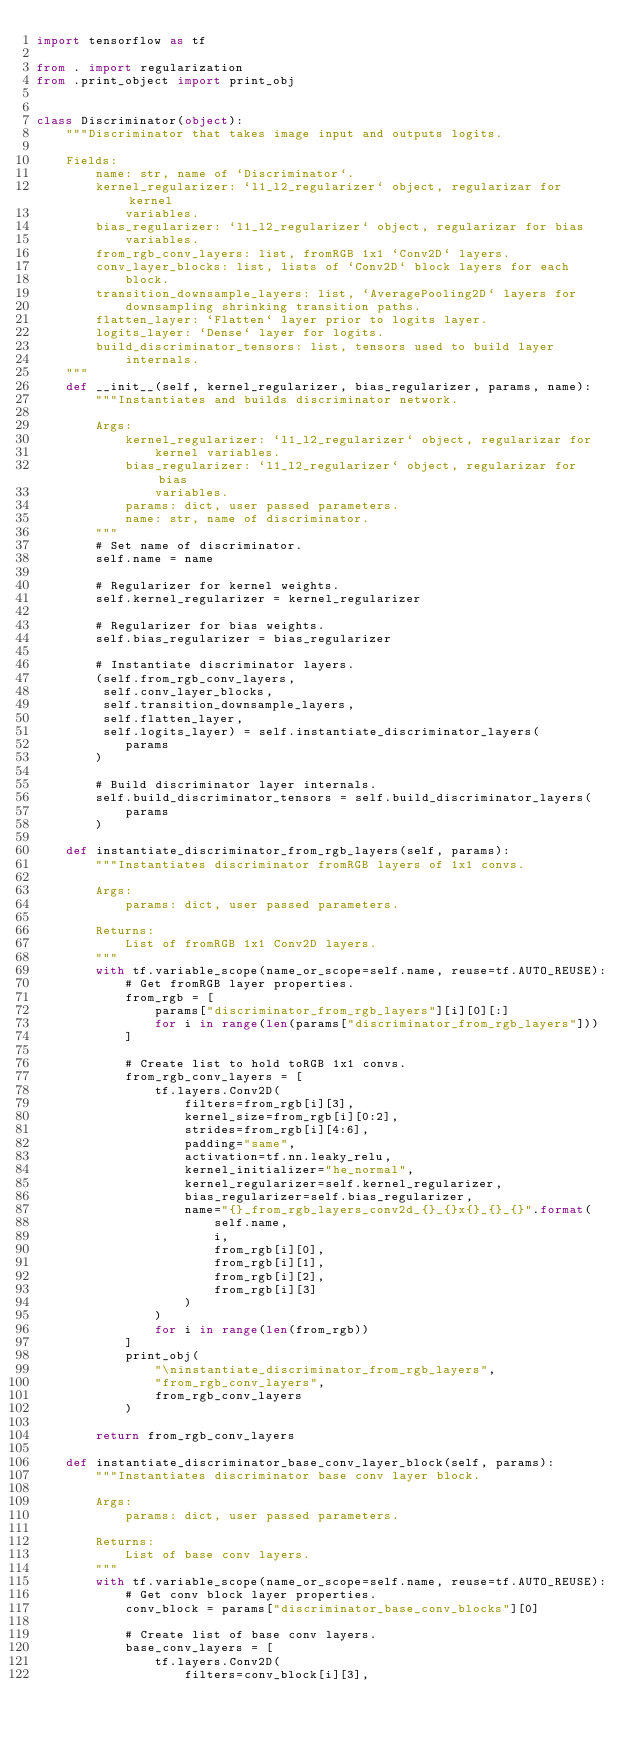<code> <loc_0><loc_0><loc_500><loc_500><_Python_>import tensorflow as tf

from . import regularization
from .print_object import print_obj


class Discriminator(object):
    """Discriminator that takes image input and outputs logits.

    Fields:
        name: str, name of `Discriminator`.
        kernel_regularizer: `l1_l2_regularizer` object, regularizar for kernel
            variables.
        bias_regularizer: `l1_l2_regularizer` object, regularizar for bias
            variables.
        from_rgb_conv_layers: list, fromRGB 1x1 `Conv2D` layers.
        conv_layer_blocks: list, lists of `Conv2D` block layers for each
            block.
        transition_downsample_layers: list, `AveragePooling2D` layers for
            downsampling shrinking transition paths.
        flatten_layer: `Flatten` layer prior to logits layer.
        logits_layer: `Dense` layer for logits.
        build_discriminator_tensors: list, tensors used to build layer
            internals.
    """
    def __init__(self, kernel_regularizer, bias_regularizer, params, name):
        """Instantiates and builds discriminator network.

        Args:
            kernel_regularizer: `l1_l2_regularizer` object, regularizar for
                kernel variables.
            bias_regularizer: `l1_l2_regularizer` object, regularizar for bias
                variables.
            params: dict, user passed parameters.
            name: str, name of discriminator.
        """
        # Set name of discriminator.
        self.name = name

        # Regularizer for kernel weights.
        self.kernel_regularizer = kernel_regularizer

        # Regularizer for bias weights.
        self.bias_regularizer = bias_regularizer

        # Instantiate discriminator layers.
        (self.from_rgb_conv_layers,
         self.conv_layer_blocks,
         self.transition_downsample_layers,
         self.flatten_layer,
         self.logits_layer) = self.instantiate_discriminator_layers(
            params
        )

        # Build discriminator layer internals.
        self.build_discriminator_tensors = self.build_discriminator_layers(
            params
        )

    def instantiate_discriminator_from_rgb_layers(self, params):
        """Instantiates discriminator fromRGB layers of 1x1 convs.

        Args:
            params: dict, user passed parameters.

        Returns:
            List of fromRGB 1x1 Conv2D layers.
        """
        with tf.variable_scope(name_or_scope=self.name, reuse=tf.AUTO_REUSE):
            # Get fromRGB layer properties.
            from_rgb = [
                params["discriminator_from_rgb_layers"][i][0][:]
                for i in range(len(params["discriminator_from_rgb_layers"]))
            ]

            # Create list to hold toRGB 1x1 convs.
            from_rgb_conv_layers = [
                tf.layers.Conv2D(
                    filters=from_rgb[i][3],
                    kernel_size=from_rgb[i][0:2],
                    strides=from_rgb[i][4:6],
                    padding="same",
                    activation=tf.nn.leaky_relu,
                    kernel_initializer="he_normal",
                    kernel_regularizer=self.kernel_regularizer,
                    bias_regularizer=self.bias_regularizer,
                    name="{}_from_rgb_layers_conv2d_{}_{}x{}_{}_{}".format(
                        self.name,
                        i,
                        from_rgb[i][0],
                        from_rgb[i][1],
                        from_rgb[i][2],
                        from_rgb[i][3]
                    )
                )
                for i in range(len(from_rgb))
            ]
            print_obj(
                "\ninstantiate_discriminator_from_rgb_layers",
                "from_rgb_conv_layers",
                from_rgb_conv_layers
            )

        return from_rgb_conv_layers

    def instantiate_discriminator_base_conv_layer_block(self, params):
        """Instantiates discriminator base conv layer block.

        Args:
            params: dict, user passed parameters.

        Returns:
            List of base conv layers.
        """
        with tf.variable_scope(name_or_scope=self.name, reuse=tf.AUTO_REUSE):
            # Get conv block layer properties.
            conv_block = params["discriminator_base_conv_blocks"][0]

            # Create list of base conv layers.
            base_conv_layers = [
                tf.layers.Conv2D(
                    filters=conv_block[i][3],</code> 